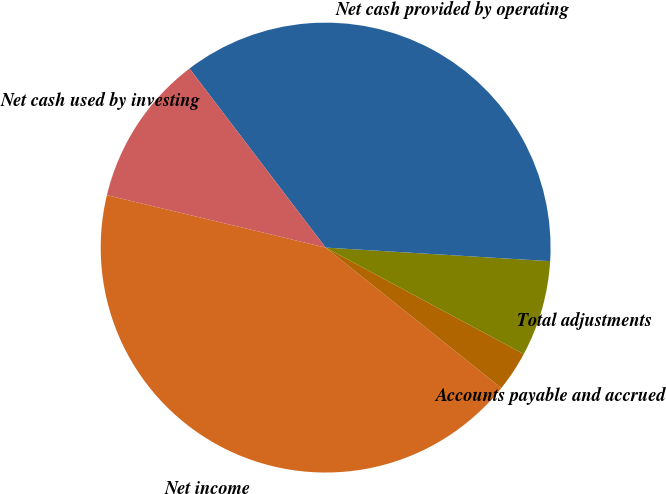Convert chart to OTSL. <chart><loc_0><loc_0><loc_500><loc_500><pie_chart><fcel>Net income<fcel>Accounts payable and accrued<fcel>Total adjustments<fcel>Net cash provided by operating<fcel>Net cash used by investing<nl><fcel>43.02%<fcel>2.88%<fcel>6.89%<fcel>36.31%<fcel>10.91%<nl></chart> 